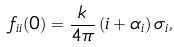<formula> <loc_0><loc_0><loc_500><loc_500>f _ { i i } ( 0 ) = \frac { k } { 4 \pi } \, ( i + \alpha _ { i } ) \, \sigma _ { i } ,</formula> 